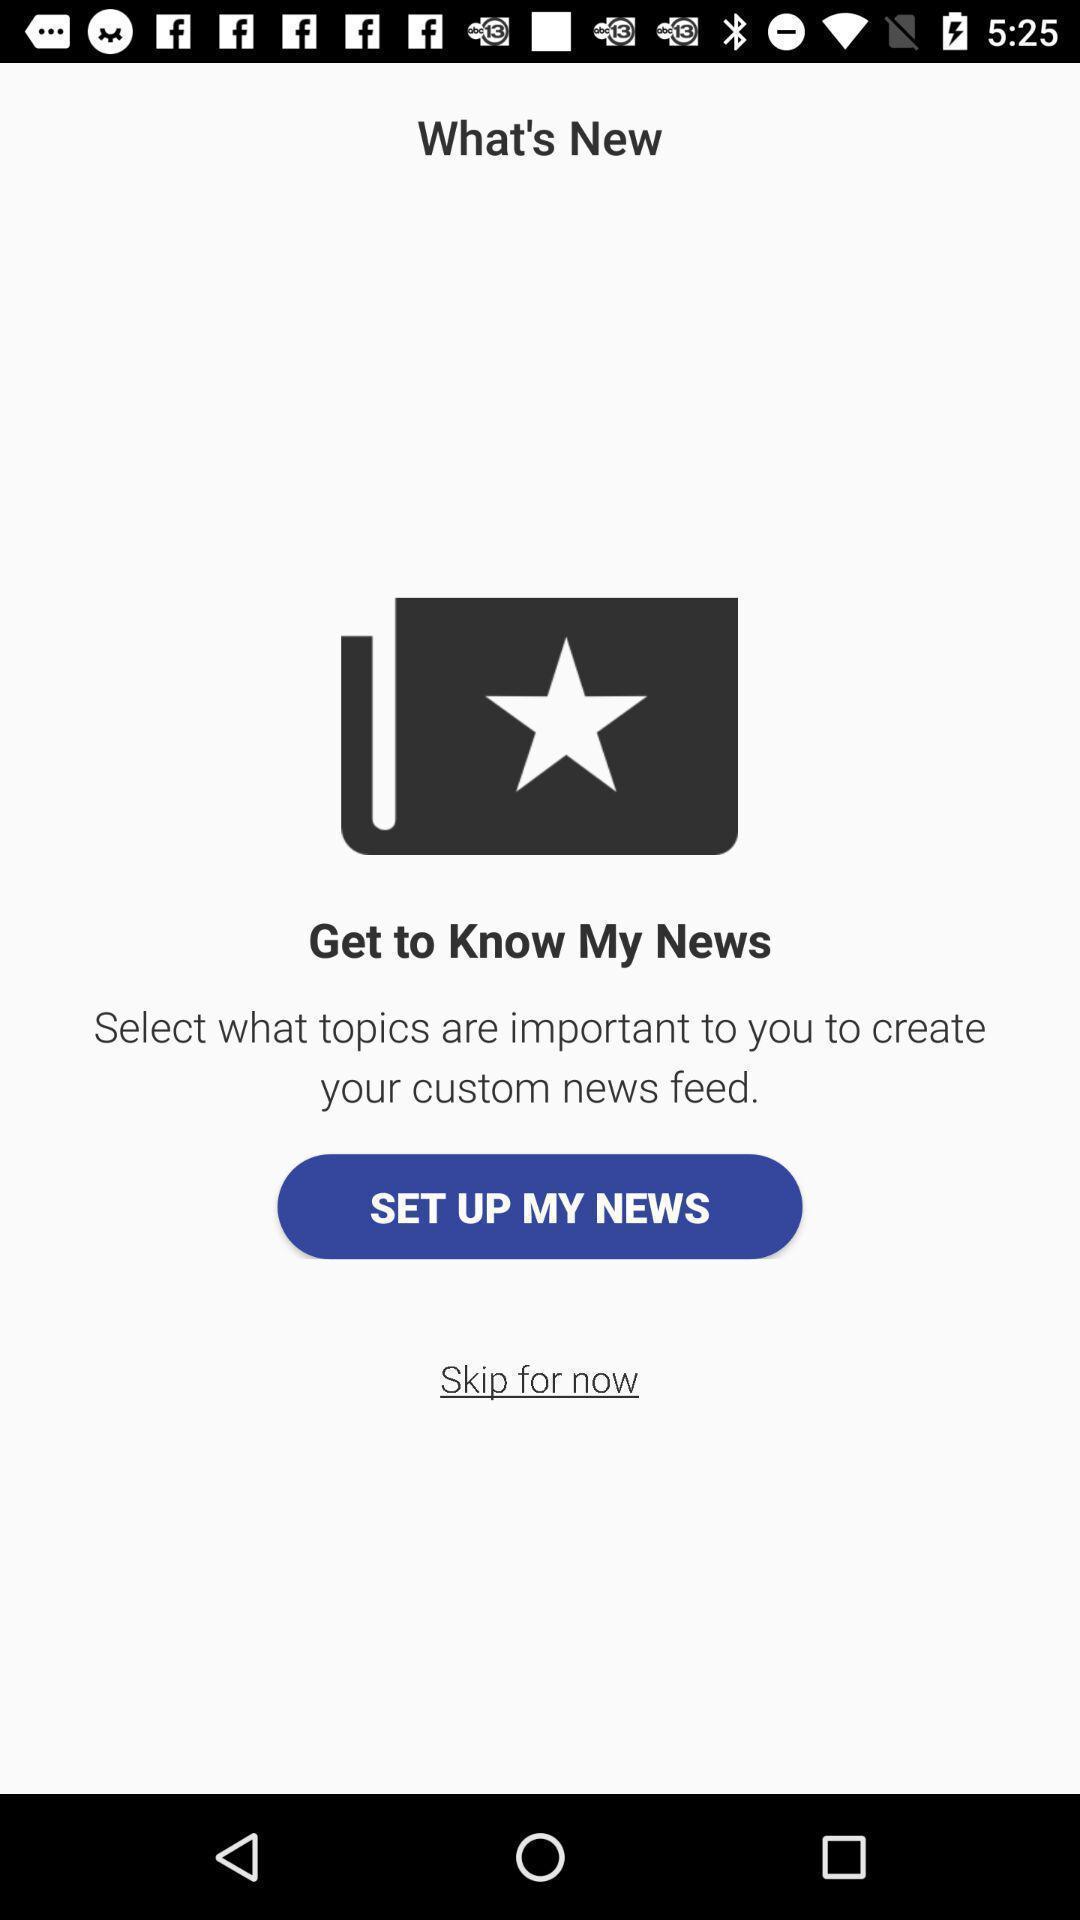What can you discern from this picture? Window displaying a news app. 